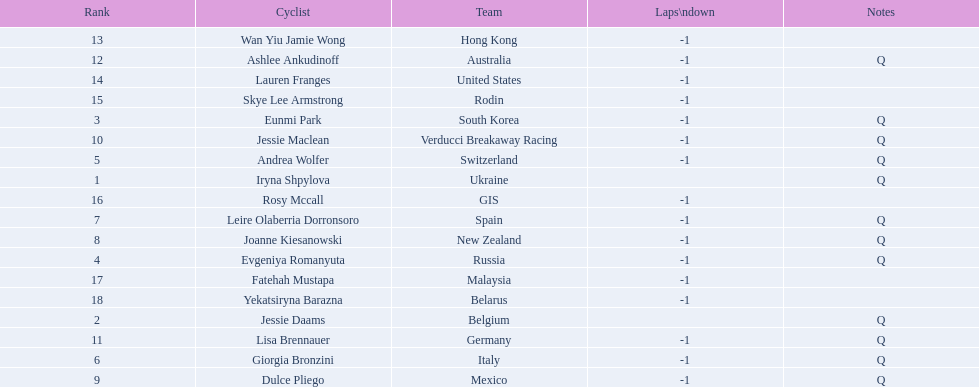Who competed in the race? Iryna Shpylova, Jessie Daams, Eunmi Park, Evgeniya Romanyuta, Andrea Wolfer, Giorgia Bronzini, Leire Olaberria Dorronsoro, Joanne Kiesanowski, Dulce Pliego, Jessie Maclean, Lisa Brennauer, Ashlee Ankudinoff, Wan Yiu Jamie Wong, Lauren Franges, Skye Lee Armstrong, Rosy Mccall, Fatehah Mustapa, Yekatsiryna Barazna. Who ranked highest in the race? Iryna Shpylova. 